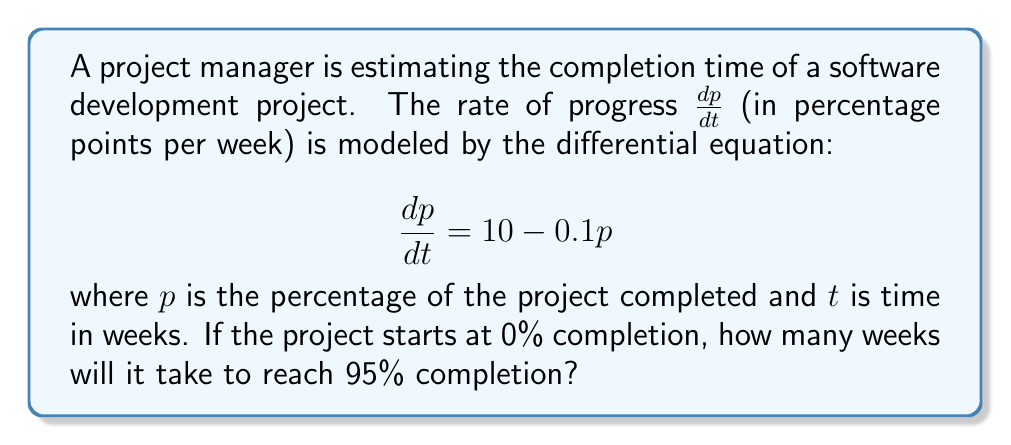Could you help me with this problem? To solve this problem, we'll follow these steps:

1) First, we need to solve the differential equation:
   $$\frac{dp}{dt} = 10 - 0.1p$$

2) This is a separable equation. We can rewrite it as:
   $$\frac{dp}{10 - 0.1p} = dt$$

3) Integrating both sides:
   $$\int \frac{dp}{10 - 0.1p} = \int dt$$

4) The left side integrates to:
   $$-10 \ln|10 - 0.1p| = t + C$$

5) Solving for $p$:
   $$10 - 0.1p = e^{-(t+C)/10} = Ae^{-t/10}$$
   $$p = 100 - 1000e^{-t/10}$$

6) Using the initial condition $p(0) = 0$, we can find $A$:
   $$0 = 100 - 1000A$$
   $$A = 0.1$$

7) So our solution is:
   $$p = 100 - 100e^{-t/10}$$

8) To find when $p = 95$, we solve:
   $$95 = 100 - 100e^{-t/10}$$

9) Simplifying:
   $$e^{-t/10} = 0.05$$

10) Taking the natural log of both sides:
    $$-t/10 = \ln(0.05)$$

11) Solving for $t$:
    $$t = -10\ln(0.05) \approx 29.96$$

Therefore, it will take approximately 30 weeks to reach 95% completion.
Answer: 30 weeks 